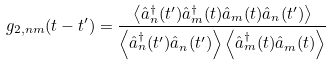Convert formula to latex. <formula><loc_0><loc_0><loc_500><loc_500>g _ { 2 , n m } ( t - t ^ { \prime } ) = \frac { \left < \hat { a } ^ { \dagger } _ { n } ( t ^ { \prime } ) \hat { a } ^ { \dagger } _ { m } ( t ) \hat { a } _ { m } ( t ) \hat { a } _ { n } ( t ^ { \prime } ) \right > } { \left < \hat { a } ^ { \dagger } _ { n } ( t ^ { \prime } ) \hat { a } _ { n } ( t ^ { \prime } ) \right > \left < \hat { a } ^ { \dagger } _ { m } ( t ) \hat { a } _ { m } ( t ) \right > }</formula> 